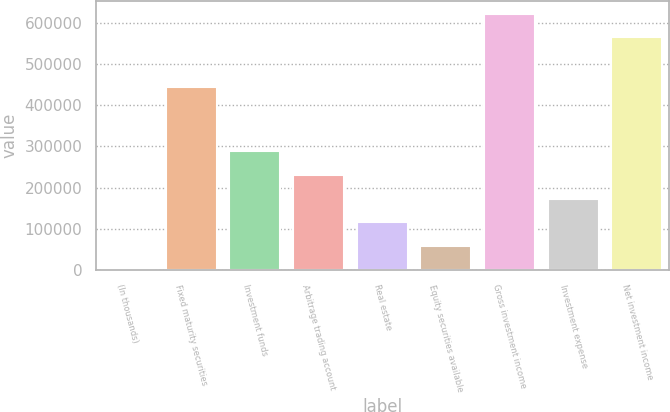<chart> <loc_0><loc_0><loc_500><loc_500><bar_chart><fcel>(In thousands)<fcel>Fixed maturity securities<fcel>Investment funds<fcel>Arbitrage trading account<fcel>Real estate<fcel>Equity securities available<fcel>Gross investment income<fcel>Investment expense<fcel>Net investment income<nl><fcel>2016<fcel>444247<fcel>287670<fcel>230539<fcel>116277<fcel>59146.7<fcel>621294<fcel>173408<fcel>564163<nl></chart> 